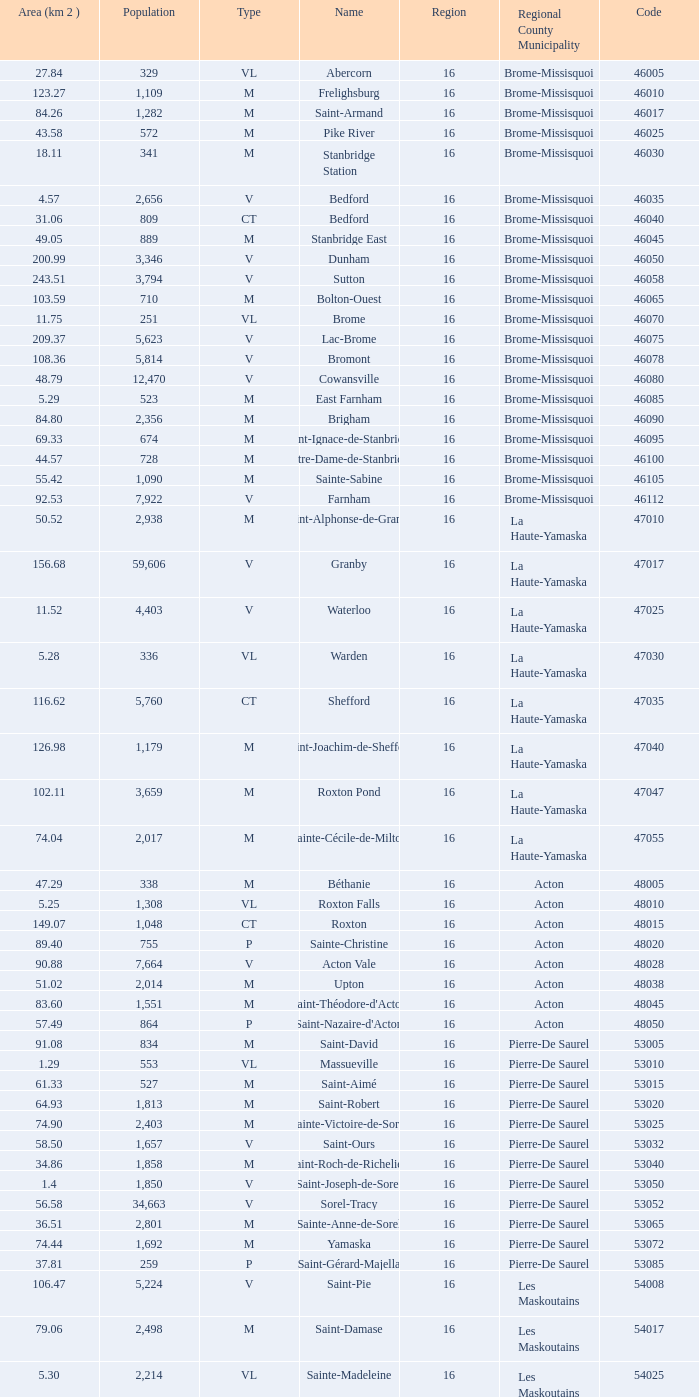Saint-Blaise-Sur-Richelieu is smaller than 68.42 km^2, what is the population of this type M municipality? None. 